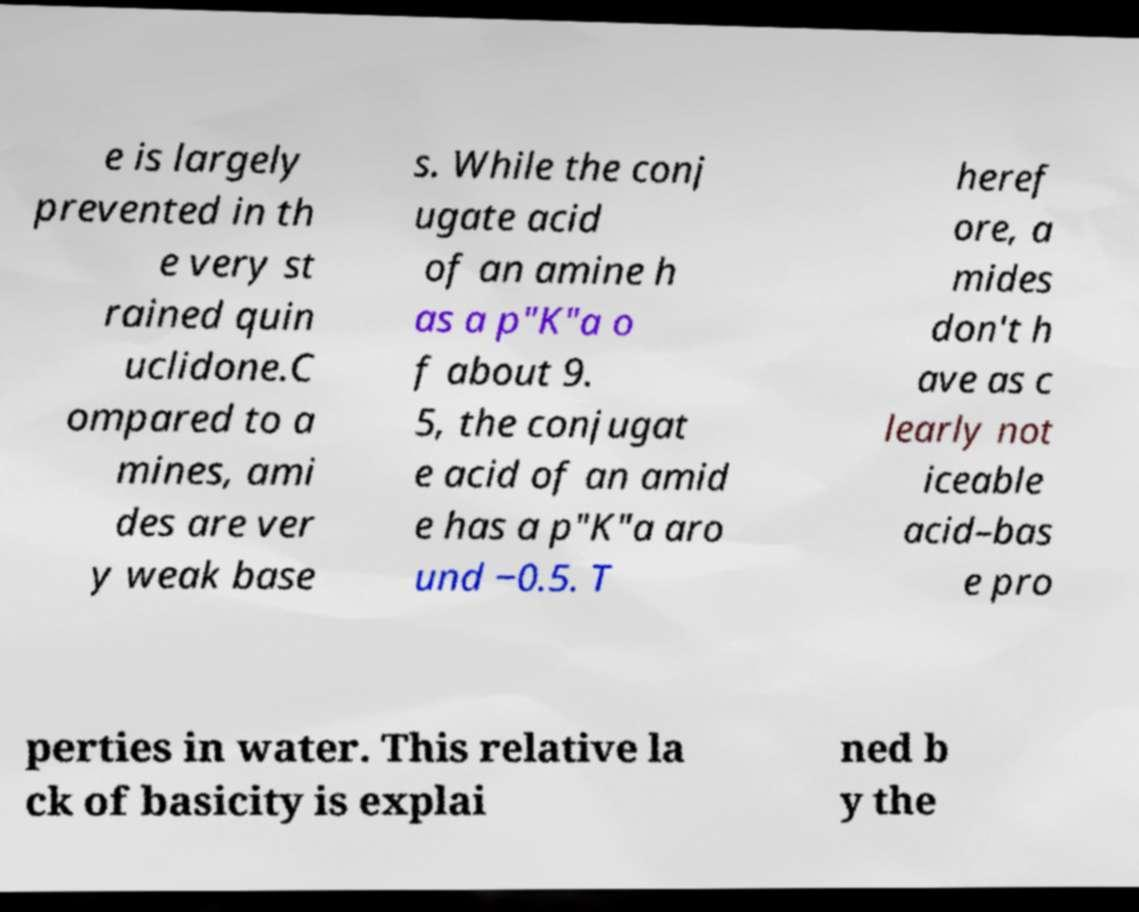Please read and relay the text visible in this image. What does it say? e is largely prevented in th e very st rained quin uclidone.C ompared to a mines, ami des are ver y weak base s. While the conj ugate acid of an amine h as a p"K"a o f about 9. 5, the conjugat e acid of an amid e has a p"K"a aro und −0.5. T heref ore, a mides don't h ave as c learly not iceable acid–bas e pro perties in water. This relative la ck of basicity is explai ned b y the 